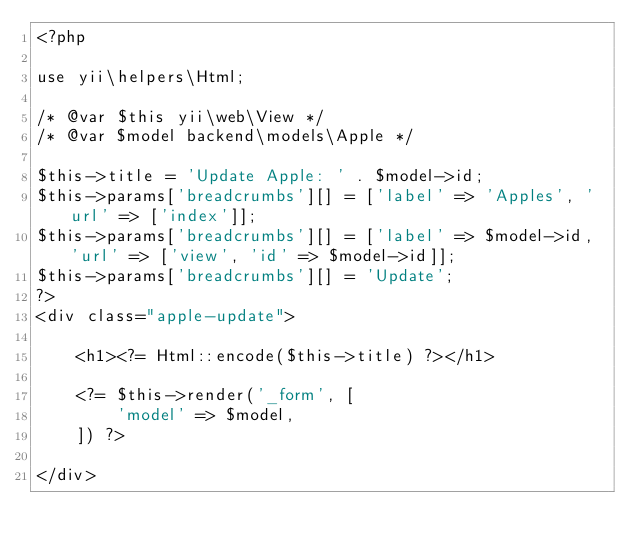<code> <loc_0><loc_0><loc_500><loc_500><_PHP_><?php

use yii\helpers\Html;

/* @var $this yii\web\View */
/* @var $model backend\models\Apple */

$this->title = 'Update Apple: ' . $model->id;
$this->params['breadcrumbs'][] = ['label' => 'Apples', 'url' => ['index']];
$this->params['breadcrumbs'][] = ['label' => $model->id, 'url' => ['view', 'id' => $model->id]];
$this->params['breadcrumbs'][] = 'Update';
?>
<div class="apple-update">

    <h1><?= Html::encode($this->title) ?></h1>

    <?= $this->render('_form', [
        'model' => $model,
    ]) ?>

</div>
</code> 